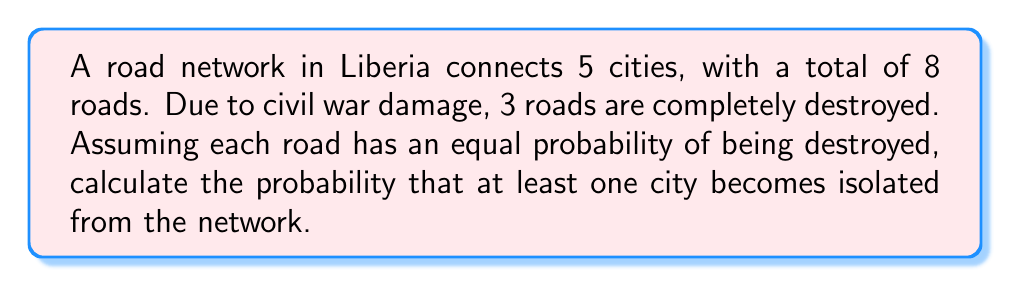Help me with this question. Let's approach this step-by-step:

1) First, we need to understand what it means for a city to be isolated. A city becomes isolated if all roads connecting it to other cities are destroyed.

2) We know there are 5 cities and 8 roads. For a city to not be isolated, it must have at least one intact road. Let's calculate the probability of this not happening.

3) The probability of a specific road being destroyed is 3/8, as 3 out of 8 roads are destroyed.

4) For a city to be isolated, all its connecting roads must be destroyed. Let's assume the minimum number of roads connecting a city is 1 (if it were 0, the city would already be isolated).

5) The probability of a city with only one road being isolated is simply 3/8.

6) For cities with more roads, the probability of isolation decreases. For example, for a city with 2 roads:
   $P(\text{isolated}) = (3/8)^2 = 9/64$

7) Without knowing the exact configuration of the network, we can't calculate the exact probability. However, we can find a lower bound by assuming each city has at least one road.

8) The probability that at least one city is isolated is the complement of the probability that no cities are isolated:

   $P(\text{at least one isolated}) = 1 - P(\text{none isolated})$

9) $P(\text{none isolated}) = (5/8)^5$, assuming each city has only one road (worst-case scenario).

10) Therefore, the probability of at least one city being isolated is:

    $P(\text{at least one isolated}) = 1 - (5/8)^5 \approx 0.7627$ or about 76.27%

This is a lower bound; the actual probability could be higher depending on the network configuration.
Answer: $1 - (5/8)^5 \approx 0.7627$ or 76.27% 